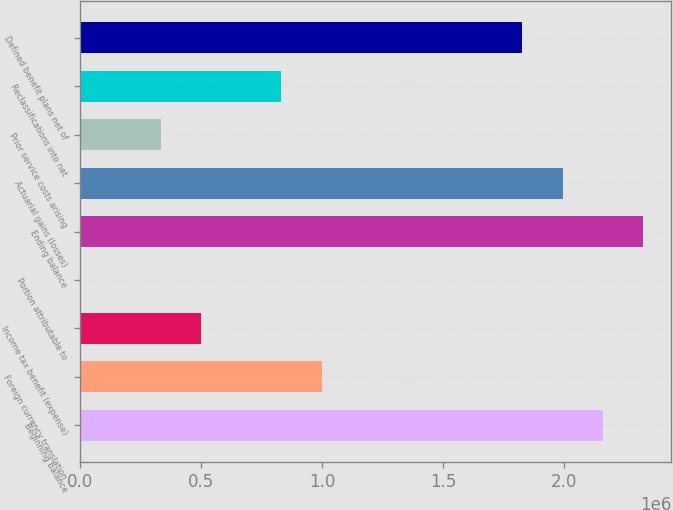<chart> <loc_0><loc_0><loc_500><loc_500><bar_chart><fcel>Beginning balance<fcel>Foreign currency translation<fcel>Income tax benefit (expense)<fcel>Portion attributable to<fcel>Ending balance<fcel>Actuarial gains (losses)<fcel>Prior service costs arising<fcel>Reclassifications into net<fcel>Defined benefit plans net of<nl><fcel>2.16003e+06<fcel>997310<fcel>499002<fcel>695<fcel>2.32613e+06<fcel>1.99392e+06<fcel>332900<fcel>831208<fcel>1.82782e+06<nl></chart> 